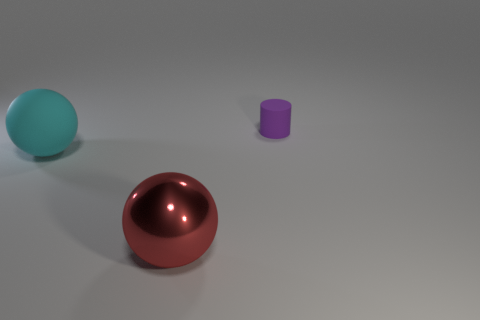Can you describe the lighting in this scene? The lighting in the scene appears diffused with soft shadows, indicating an overcast or an ambient light source, which creates a calm and even illumination on the objects. 